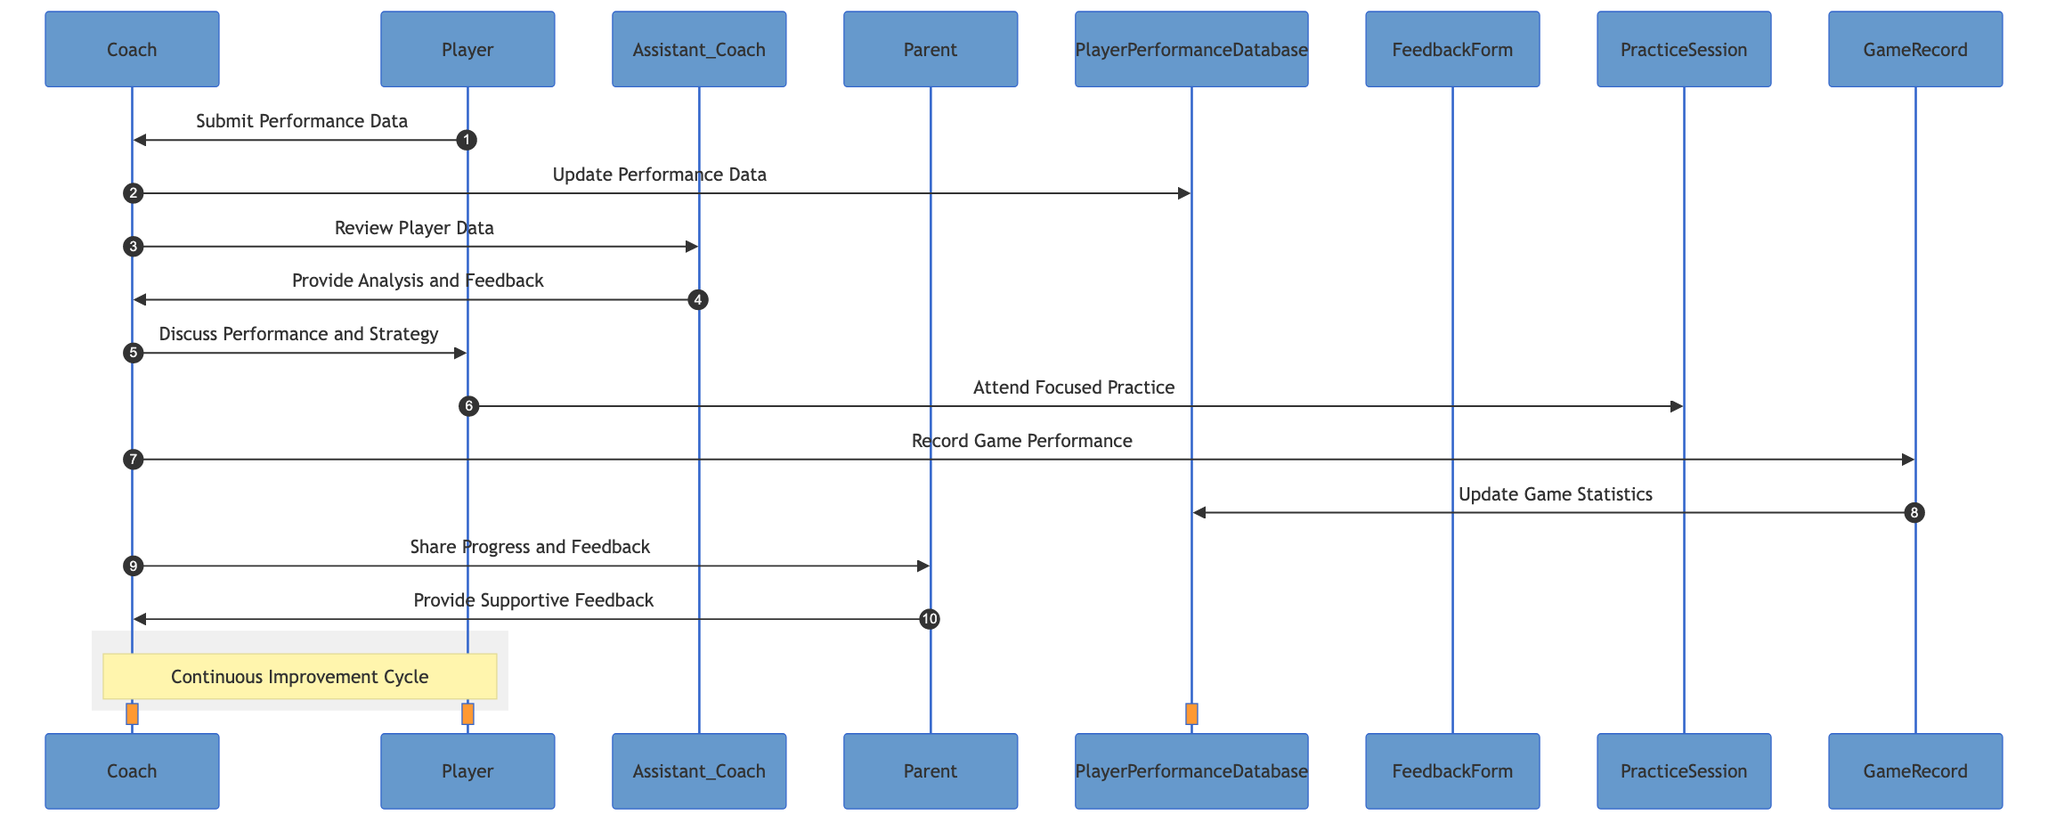What is the first message in the sequence? The first message in the sequence is from the Player to the Coach, which is "Submit Performance Data." This can be found by following the flow from the Player actor to the Coach actor.
Answer: Submit Performance Data How many actors are present in the diagram? The diagram includes four actors: Coach, Player, Assistant Coach, and Parent. This is determined by counting the distinct actors listed at the top of the sequence diagram.
Answer: Four Who provides analysis and feedback to the Coach? The Assistant Coach provides analysis and feedback to the Coach. This is shown in the message flow where the Coach sends a request to the Assistant Coach to "Review Player Data" and the Assistant Coach responds with "Provide Analysis and Feedback."
Answer: Assistant Coach What message does the Coach send to the Parent? The Coach sends the message "Share Progress and Feedback" to the Parent. This can be verified by following the flow of messages in the sequence where the Coach interacts with the Parent.
Answer: Share Progress and Feedback What action does the Player take after discussing performance with the Coach? After discussing performance and strategy with the Coach, the Player attends a focused practice session. This is indicated in the sequence as a direct response from the Player following the Coach’s discussion.
Answer: Attend Focused Practice What updates game statistics in the Player Performance Database? The Game Record updates game statistics in the Player Performance Database. This is shown in the message flow from the Game Record to the Player Performance Database, indicating that game statistics are being updated.
Answer: Game Record What type of diagram is this? This is a sequence diagram that visually represents interactions among various actors and objects in tracking player progress and feedback throughout the season. The title and structure are indicative of it being a sequence diagram specifically.
Answer: Sequence diagram Which two actors are involved in the continuous improvement cycle? The two actors involved in the continuous improvement cycle are the Coach and the Player, as indicated by the note over them in the rectangle section that describes this cycle.
Answer: Coach, Player 